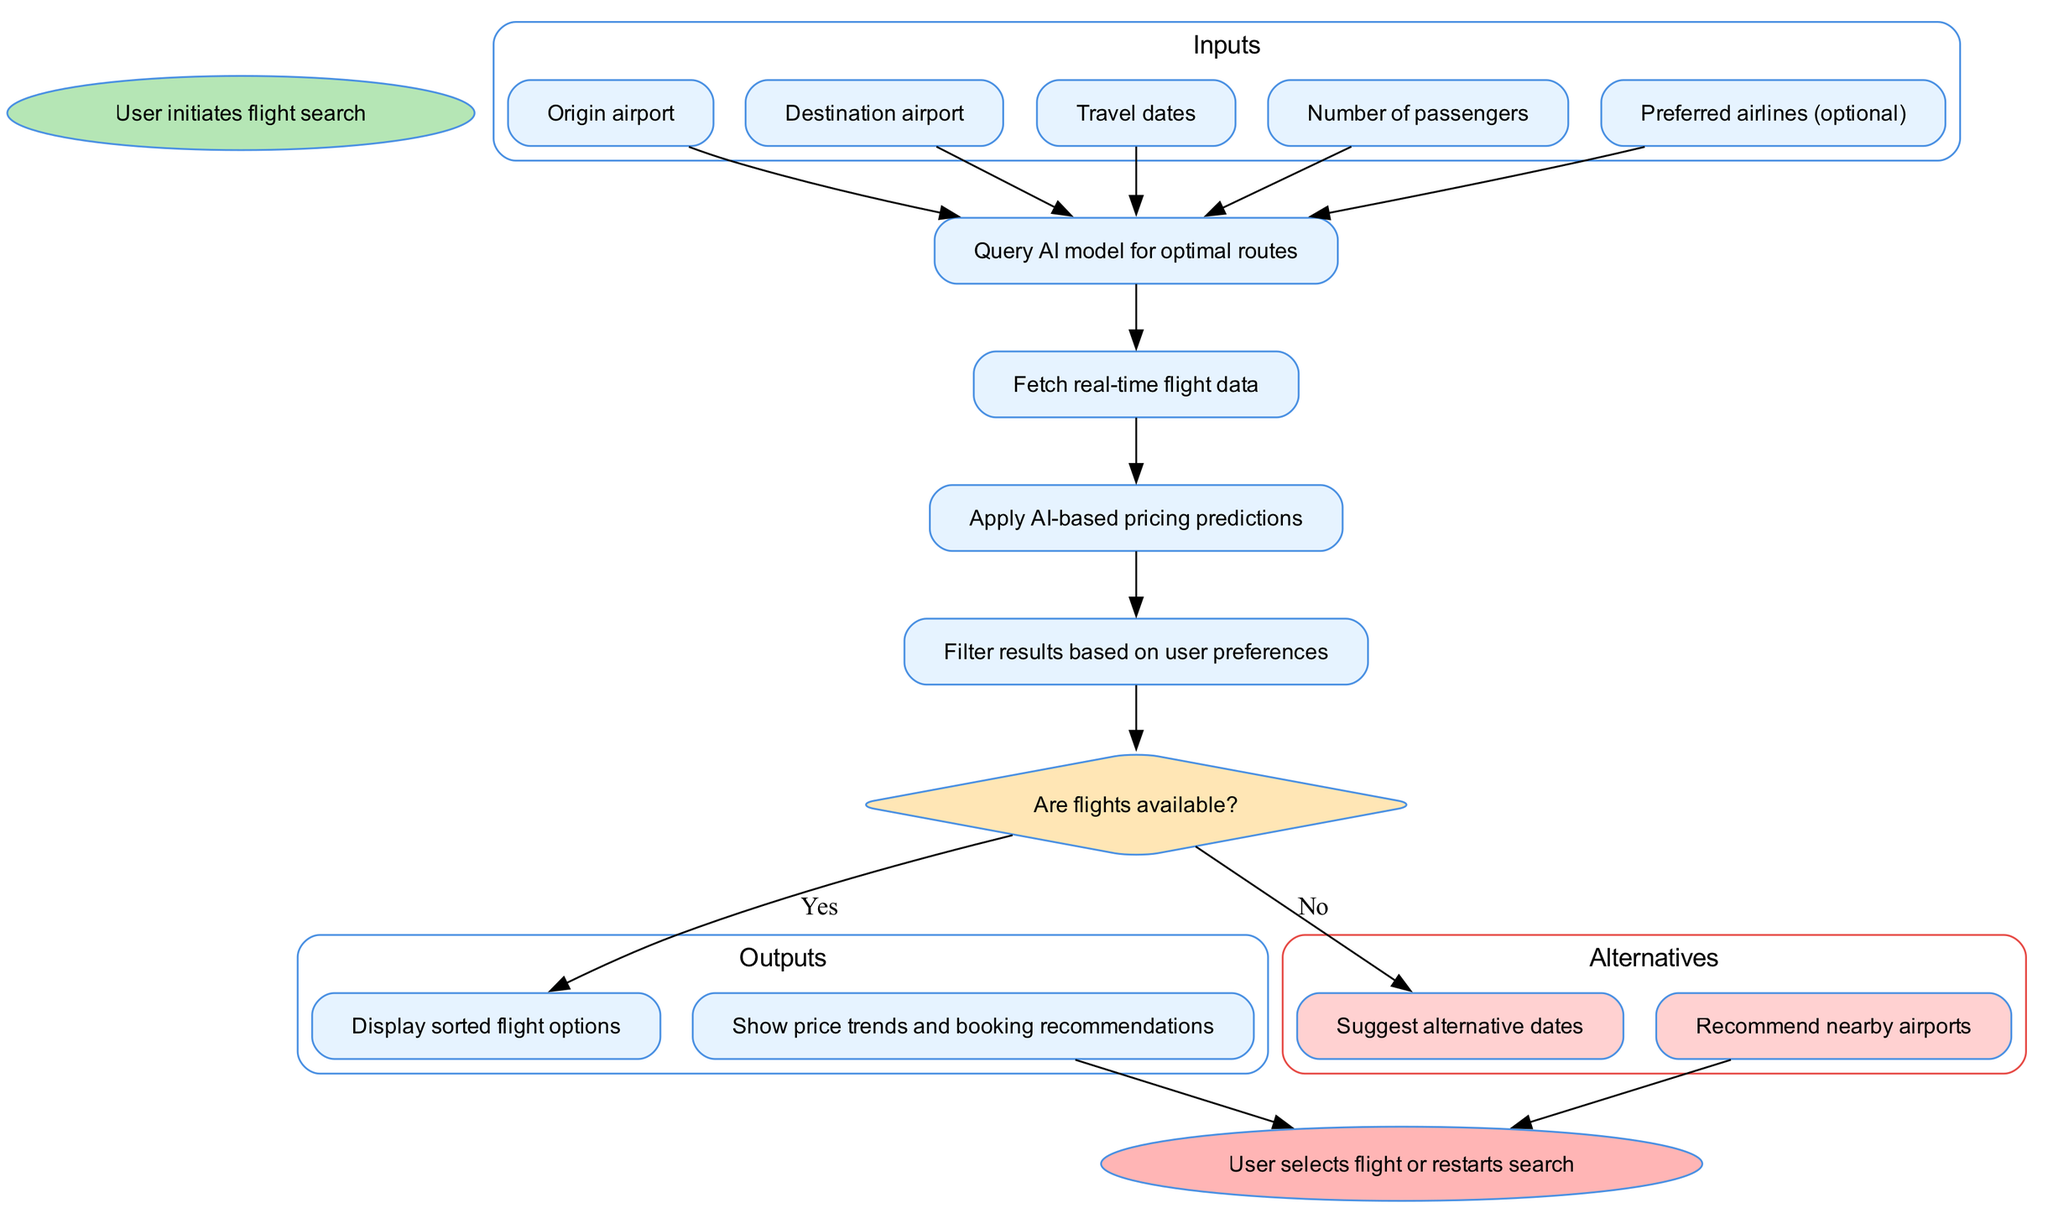What inputs does the user provide to initiate the flight search? The diagram lists five specific inputs that the user must provide to initiate the flight search process: origin airport, destination airport, travel dates, number of passengers, and preferred airlines (optional).
Answer: Origin airport, Destination airport, Travel dates, Number of passengers, Preferred airlines (optional) How many processes are involved after the inputs? The diagram illustrates a sequence of four processes that occur after the inputs are provided, specifically: querying the AI model for optimal routes, fetching real-time flight data, applying AI-based pricing predictions, and filtering results based on user preferences.
Answer: Four What does the decision node in the flow chart ask? The decision node in the diagram is formulated as a question: "Are flights available?" This indicates that the next steps depend on whether the answer to this question is yes or no.
Answer: Are flights available? What happens if no flights are available? The diagram indicates that if the decision node answers "No," the flow transitions to suggest alternative options, which include suggesting alternative dates and recommending nearby airports.
Answer: Suggest alternative dates, Recommend nearby airports What are the outputs shown after the decision node when flights are available? If flights are available, the diagram specifies that the outputs include displaying sorted flight options and showing price trends and booking recommendations as part of the user experience.
Answer: Display sorted flight options, Show price trends and booking recommendations How does the flow proceed after the processes are completed? After completing all processes, the flow of the diagram moves to the decision node where the system checks for flight availability. Depending on the outcome, it either leads to outputs if flights are available or alternatives if they are not.
Answer: To the decision node What is the color indicating the start of the flow chart? In the flow chart, the start node is represented in a greenish color (#B5E6B5), which visually distinguishes it from other elements in the diagram, such as inputs or processes.
Answer: Greenish color What does the end node signify in the diagram? The end node in the diagram signifies that the user either selects a flight from the displayed options or opts to restart the search process, marking the conclusion of the flight search operation.
Answer: User selects flight or restarts search 